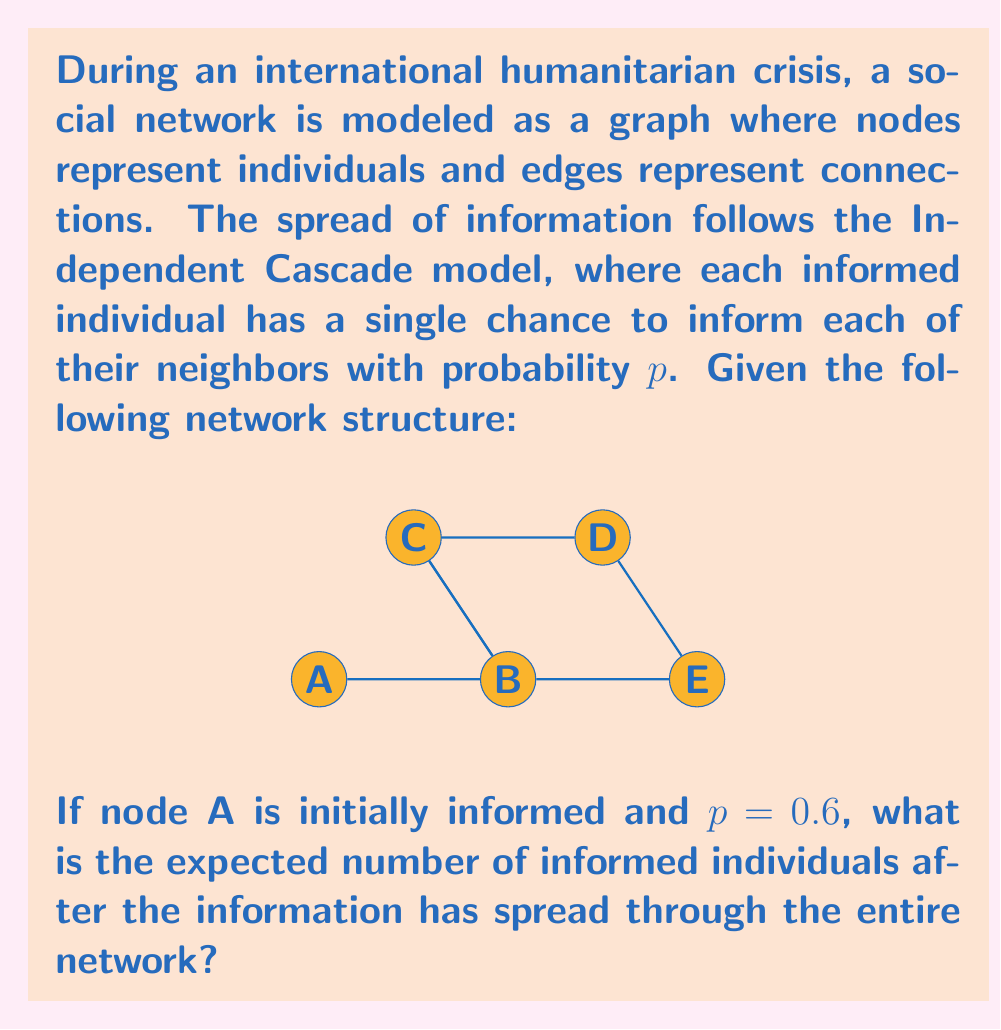Show me your answer to this math problem. Let's approach this step-by-step:

1) First, we need to understand how the Independent Cascade model works. Each informed node has one chance to inform each of its neighbors with probability $p$.

2) Starting from node A, we can calculate the probability of informing each node:

   - P(B informed) = 0.6
   - P(C informed directly from A) = 0

3) If B is informed, it can then inform C, D, and E:
   
   - P(C informed | B informed) = 0.6
   - P(D informed | B informed) = 0.6
   - P(E informed | B informed) = 0.6

4) The probability of C being informed is:
   
   P(C informed) = P(B informed) * P(C informed | B informed) = 0.6 * 0.6 = 0.36

5) For D and E, they can only be informed if B is informed:
   
   P(D informed) = P(E informed) = 0.6 * 0.6 = 0.36

6) Now, we can calculate the expected number of informed individuals:

   E(informed) = 1 (A is always informed) + P(B informed) + P(C informed) + P(D informed) + P(E informed)
                = 1 + 0.6 + 0.36 + 0.36 + 0.36
                = 2.68

Therefore, the expected number of informed individuals is 2.68.
Answer: 2.68 